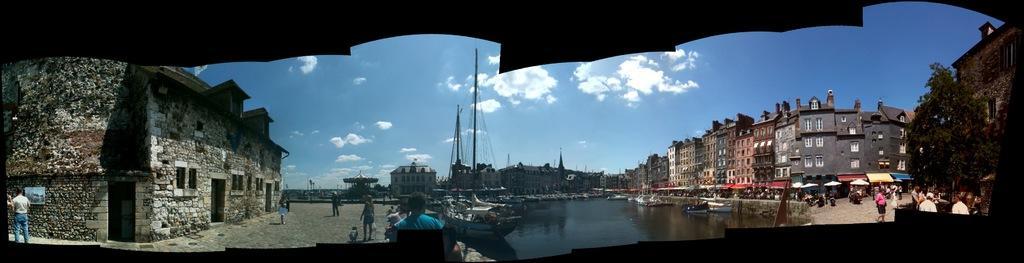How would you summarize this image in a sentence or two? In this image it seems like it is a wide angle photo. In the middle there is water. In the water there are so many boats. On the right side there are so many buildings one beside the other. Below the buildings there are so many shops on the road. On the left side there is a stone house. At the top there is the sky. There are few persons standing on the floor beside the house. 